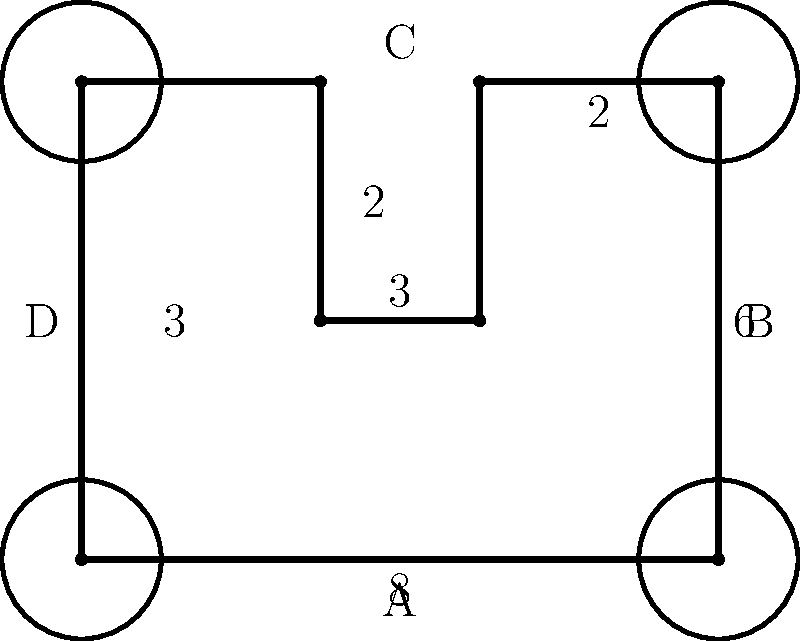The diagram represents the layout of an ancient city's fortifications. The main wall forms an irregular octagon, with circular towers at each corner. If the radius of each tower is 1 unit, and the dimensions are as shown (in arbitrary units), calculate the total perimeter of the fortification system, including both the walls and the exposed portions of the towers. Round your answer to two decimal places. To solve this problem, we need to calculate the perimeter of the octagonal wall and add the exposed portions of the circular towers. Let's break it down step-by-step:

1. Calculate the perimeter of the octagonal wall:
   * Sum of all straight segments: $8 + 6 + 2 + 3 + 3 + 2 + 6 + 3 = 33$ units

2. Calculate the exposed portion of each tower:
   * Circumference of a full circle: $2\pi r = 2\pi(1) = 2\pi$
   * Exposed portion: $\frac{3}{4}$ of the circumference (as $\frac{1}{4}$ is inside the wall)
   * Exposed portion of one tower: $\frac{3}{4} \cdot 2\pi = \frac{3\pi}{2}$

3. Total exposed portion of all four towers:
   * $4 \cdot \frac{3\pi}{2} = 6\pi$

4. Sum up the total perimeter:
   * Total perimeter = Wall perimeter + Exposed tower perimeter
   * $33 + 6\pi$

5. Calculate the numerical value:
   * $33 + 6\pi \approx 33 + 18.85 = 51.85$

6. Round to two decimal places:
   * $51.85$ units

This solution combines the straight wall segments with the curved tower sections, providing a comprehensive measure of the entire fortification system's perimeter.
Answer: $51.85$ units 